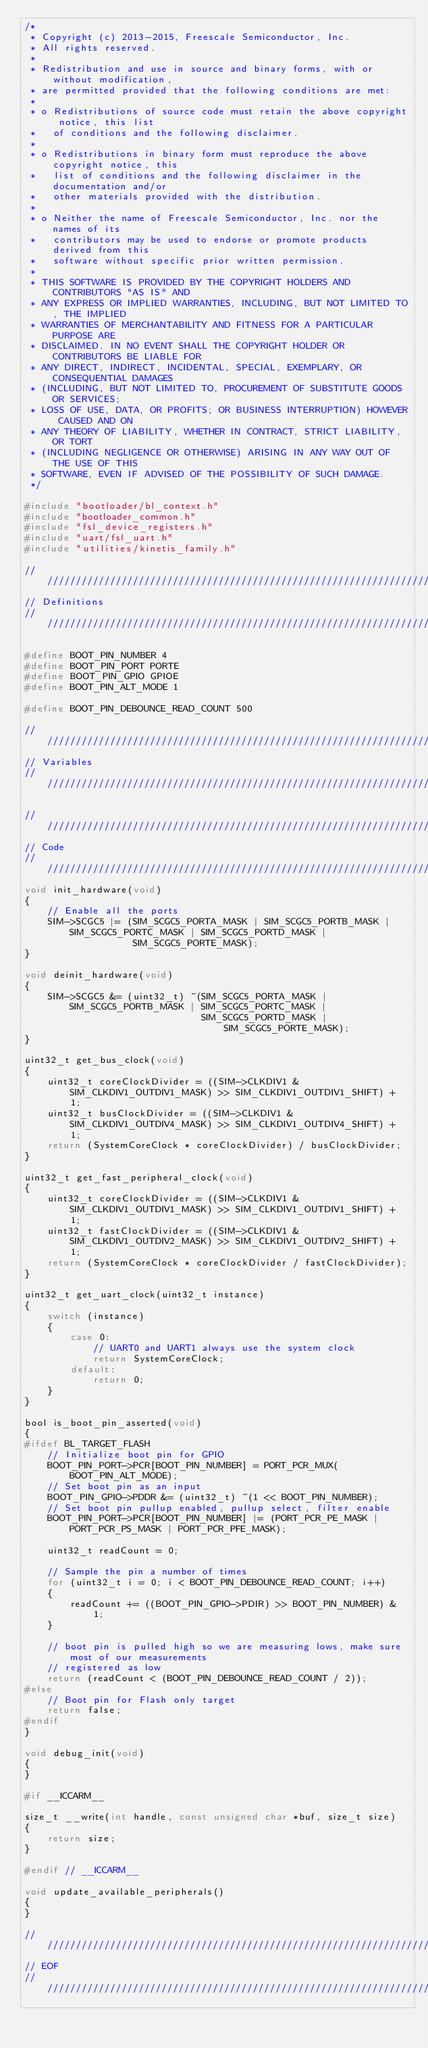<code> <loc_0><loc_0><loc_500><loc_500><_C_>/*
 * Copyright (c) 2013-2015, Freescale Semiconductor, Inc.
 * All rights reserved.
 *
 * Redistribution and use in source and binary forms, with or without modification,
 * are permitted provided that the following conditions are met:
 *
 * o Redistributions of source code must retain the above copyright notice, this list
 *   of conditions and the following disclaimer.
 *
 * o Redistributions in binary form must reproduce the above copyright notice, this
 *   list of conditions and the following disclaimer in the documentation and/or
 *   other materials provided with the distribution.
 *
 * o Neither the name of Freescale Semiconductor, Inc. nor the names of its
 *   contributors may be used to endorse or promote products derived from this
 *   software without specific prior written permission.
 *
 * THIS SOFTWARE IS PROVIDED BY THE COPYRIGHT HOLDERS AND CONTRIBUTORS "AS IS" AND
 * ANY EXPRESS OR IMPLIED WARRANTIES, INCLUDING, BUT NOT LIMITED TO, THE IMPLIED
 * WARRANTIES OF MERCHANTABILITY AND FITNESS FOR A PARTICULAR PURPOSE ARE
 * DISCLAIMED. IN NO EVENT SHALL THE COPYRIGHT HOLDER OR CONTRIBUTORS BE LIABLE FOR
 * ANY DIRECT, INDIRECT, INCIDENTAL, SPECIAL, EXEMPLARY, OR CONSEQUENTIAL DAMAGES
 * (INCLUDING, BUT NOT LIMITED TO, PROCUREMENT OF SUBSTITUTE GOODS OR SERVICES;
 * LOSS OF USE, DATA, OR PROFITS; OR BUSINESS INTERRUPTION) HOWEVER CAUSED AND ON
 * ANY THEORY OF LIABILITY, WHETHER IN CONTRACT, STRICT LIABILITY, OR TORT
 * (INCLUDING NEGLIGENCE OR OTHERWISE) ARISING IN ANY WAY OUT OF THE USE OF THIS
 * SOFTWARE, EVEN IF ADVISED OF THE POSSIBILITY OF SUCH DAMAGE.
 */

#include "bootloader/bl_context.h"
#include "bootloader_common.h"
#include "fsl_device_registers.h"
#include "uart/fsl_uart.h"
#include "utilities/kinetis_family.h"

////////////////////////////////////////////////////////////////////////////////
// Definitions
////////////////////////////////////////////////////////////////////////////////

#define BOOT_PIN_NUMBER 4
#define BOOT_PIN_PORT PORTE
#define BOOT_PIN_GPIO GPIOE
#define BOOT_PIN_ALT_MODE 1

#define BOOT_PIN_DEBOUNCE_READ_COUNT 500

////////////////////////////////////////////////////////////////////////////////
// Variables
////////////////////////////////////////////////////////////////////////////////

////////////////////////////////////////////////////////////////////////////////
// Code
////////////////////////////////////////////////////////////////////////////////
void init_hardware(void)
{
    // Enable all the ports
    SIM->SCGC5 |= (SIM_SCGC5_PORTA_MASK | SIM_SCGC5_PORTB_MASK | SIM_SCGC5_PORTC_MASK | SIM_SCGC5_PORTD_MASK |
                   SIM_SCGC5_PORTE_MASK);
}

void deinit_hardware(void)
{
    SIM->SCGC5 &= (uint32_t) ~(SIM_SCGC5_PORTA_MASK | SIM_SCGC5_PORTB_MASK | SIM_SCGC5_PORTC_MASK |
                               SIM_SCGC5_PORTD_MASK | SIM_SCGC5_PORTE_MASK);
}

uint32_t get_bus_clock(void)
{
    uint32_t coreClockDivider = ((SIM->CLKDIV1 & SIM_CLKDIV1_OUTDIV1_MASK) >> SIM_CLKDIV1_OUTDIV1_SHIFT) + 1;
    uint32_t busClockDivider = ((SIM->CLKDIV1 & SIM_CLKDIV1_OUTDIV4_MASK) >> SIM_CLKDIV1_OUTDIV4_SHIFT) + 1;
    return (SystemCoreClock * coreClockDivider) / busClockDivider;
}

uint32_t get_fast_peripheral_clock(void)
{
    uint32_t coreClockDivider = ((SIM->CLKDIV1 & SIM_CLKDIV1_OUTDIV1_MASK) >> SIM_CLKDIV1_OUTDIV1_SHIFT) + 1;
    uint32_t fastClockDivider = ((SIM->CLKDIV1 & SIM_CLKDIV1_OUTDIV2_MASK) >> SIM_CLKDIV1_OUTDIV2_SHIFT) + 1;
    return (SystemCoreClock * coreClockDivider / fastClockDivider);
}

uint32_t get_uart_clock(uint32_t instance)
{
    switch (instance)
    {
        case 0:
            // UART0 and UART1 always use the system clock
            return SystemCoreClock;
        default:
            return 0;
    }
}

bool is_boot_pin_asserted(void)
{
#ifdef BL_TARGET_FLASH
    // Initialize boot pin for GPIO
    BOOT_PIN_PORT->PCR[BOOT_PIN_NUMBER] = PORT_PCR_MUX(BOOT_PIN_ALT_MODE);
    // Set boot pin as an input
    BOOT_PIN_GPIO->PDDR &= (uint32_t) ~(1 << BOOT_PIN_NUMBER);
    // Set boot pin pullup enabled, pullup select, filter enable
    BOOT_PIN_PORT->PCR[BOOT_PIN_NUMBER] |= (PORT_PCR_PE_MASK | PORT_PCR_PS_MASK | PORT_PCR_PFE_MASK);

    uint32_t readCount = 0;

    // Sample the pin a number of times
    for (uint32_t i = 0; i < BOOT_PIN_DEBOUNCE_READ_COUNT; i++)
    {
        readCount += ((BOOT_PIN_GPIO->PDIR) >> BOOT_PIN_NUMBER) & 1;
    }

    // boot pin is pulled high so we are measuring lows, make sure most of our measurements
    // registered as low
    return (readCount < (BOOT_PIN_DEBOUNCE_READ_COUNT / 2));
#else
    // Boot pin for Flash only target
    return false;
#endif
}

void debug_init(void)
{
}

#if __ICCARM__

size_t __write(int handle, const unsigned char *buf, size_t size)
{
    return size;
}

#endif // __ICCARM__

void update_available_peripherals()
{
}

////////////////////////////////////////////////////////////////////////////////
// EOF
////////////////////////////////////////////////////////////////////////////////
</code> 